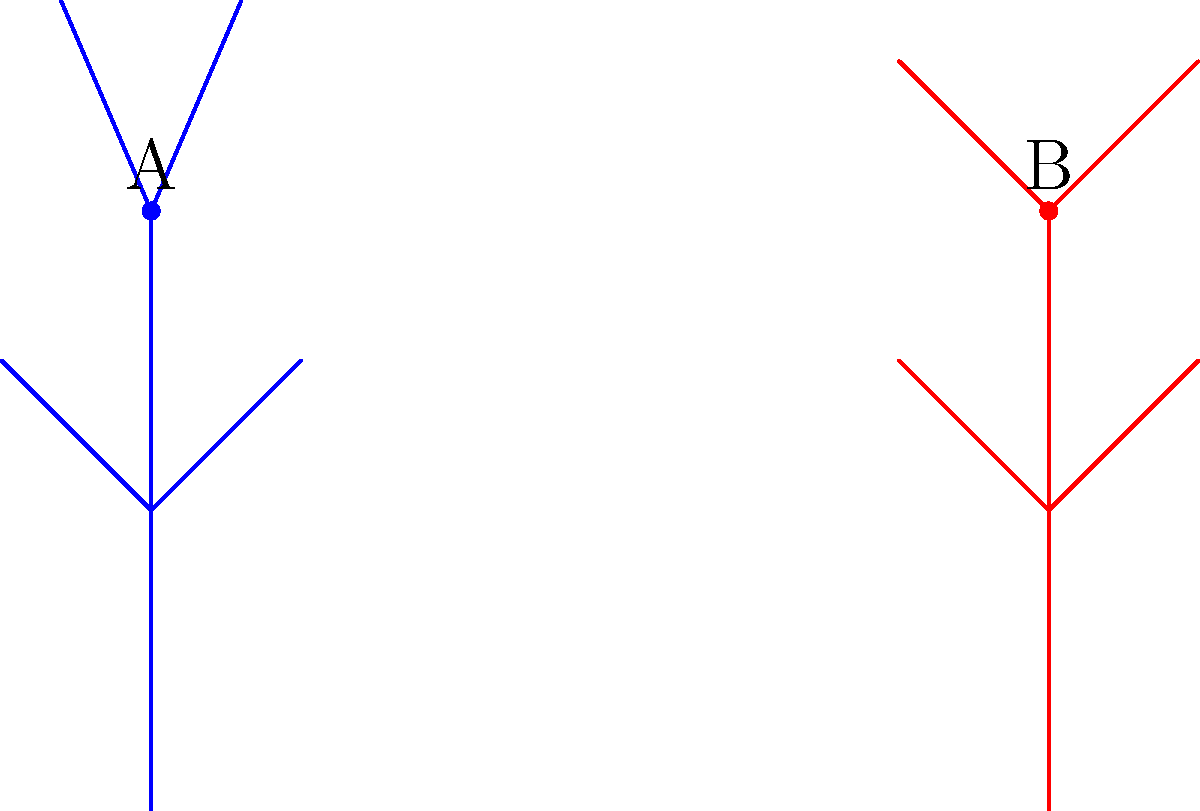In this stick figure representation of Richard Armitage's dance postures, which of the following statements is true about the difference between posture A and posture B?
a) Posture B has a wider stance
b) Posture A has higher arm positions
c) Posture B shows more forward lean
d) Posture A demonstrates more symmetry To analyze the differences between posture A (blue) and posture B (red), let's examine each aspect step-by-step:

1. Stance width:
   - Posture A: feet are positioned at (0,0) and (0,1)
   - Posture B: feet are positioned at (3,0) and (3,1)
   The horizontal distance between feet is the same for both postures.

2. Arm positions:
   - Posture A: arms reach to y-coordinate 2.7
   - Posture B: arms reach to y-coordinate 2.5
   Posture A clearly has higher arm positions.

3. Forward lean:
   - Posture A: the head (top point) is directly above the feet
   - Posture B: the head is in line with the feet
   Neither posture shows a noticeable forward lean.

4. Symmetry:
   - Posture A: arms are symmetrically positioned at (-0.3,2.7) and (0.3,2.7)
   - Posture B: arms are symmetrically positioned at (2.5,2.5) and (3.5,2.5)
   Both postures demonstrate equal symmetry.

Based on this analysis, the only true statement is that Posture A has higher arm positions.
Answer: b) Posture A has higher arm positions 